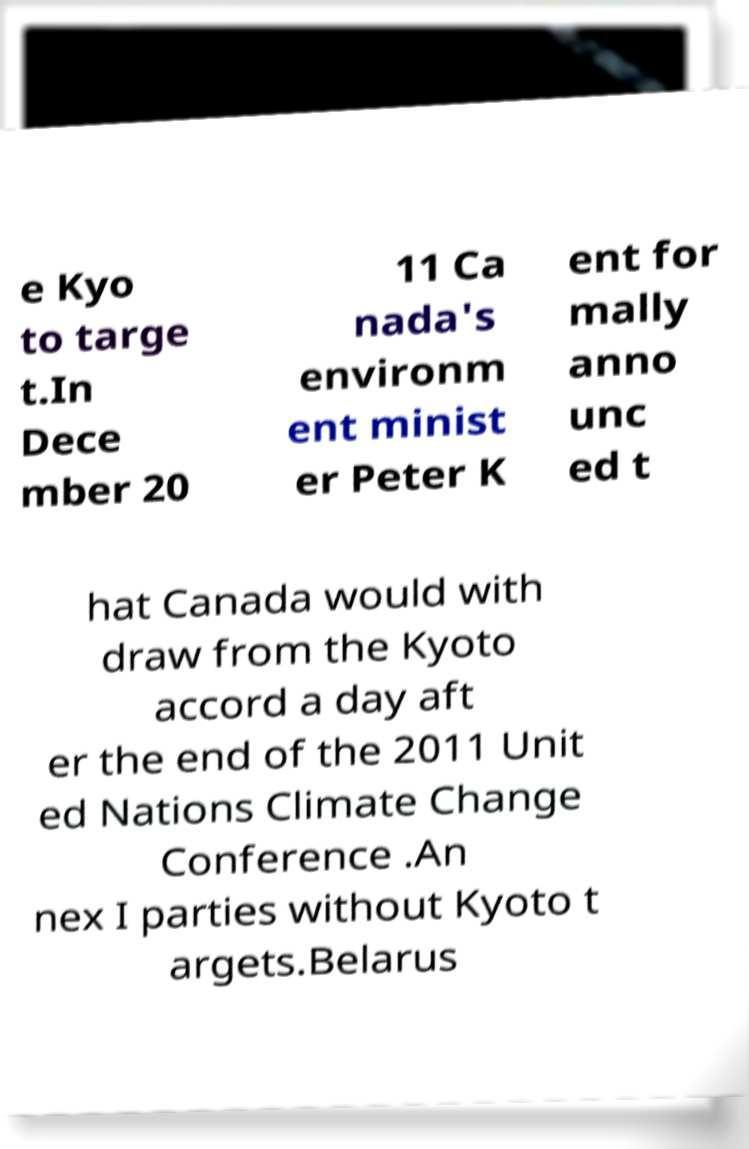I need the written content from this picture converted into text. Can you do that? e Kyo to targe t.In Dece mber 20 11 Ca nada's environm ent minist er Peter K ent for mally anno unc ed t hat Canada would with draw from the Kyoto accord a day aft er the end of the 2011 Unit ed Nations Climate Change Conference .An nex I parties without Kyoto t argets.Belarus 